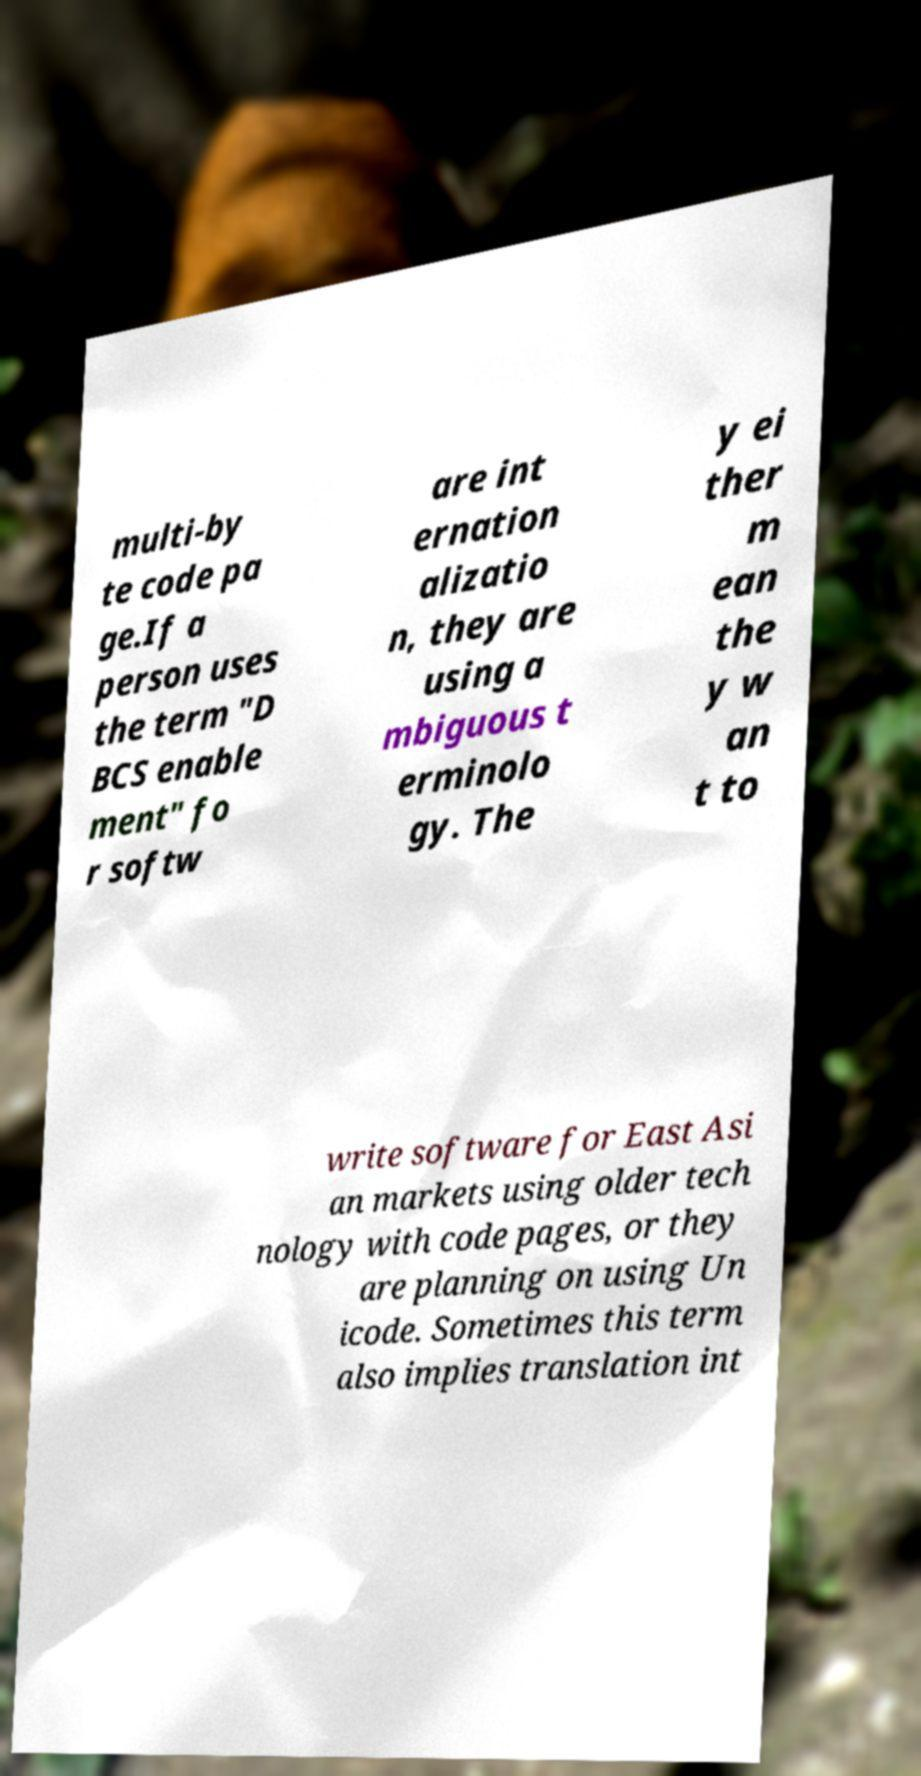Please identify and transcribe the text found in this image. multi-by te code pa ge.If a person uses the term "D BCS enable ment" fo r softw are int ernation alizatio n, they are using a mbiguous t erminolo gy. The y ei ther m ean the y w an t to write software for East Asi an markets using older tech nology with code pages, or they are planning on using Un icode. Sometimes this term also implies translation int 